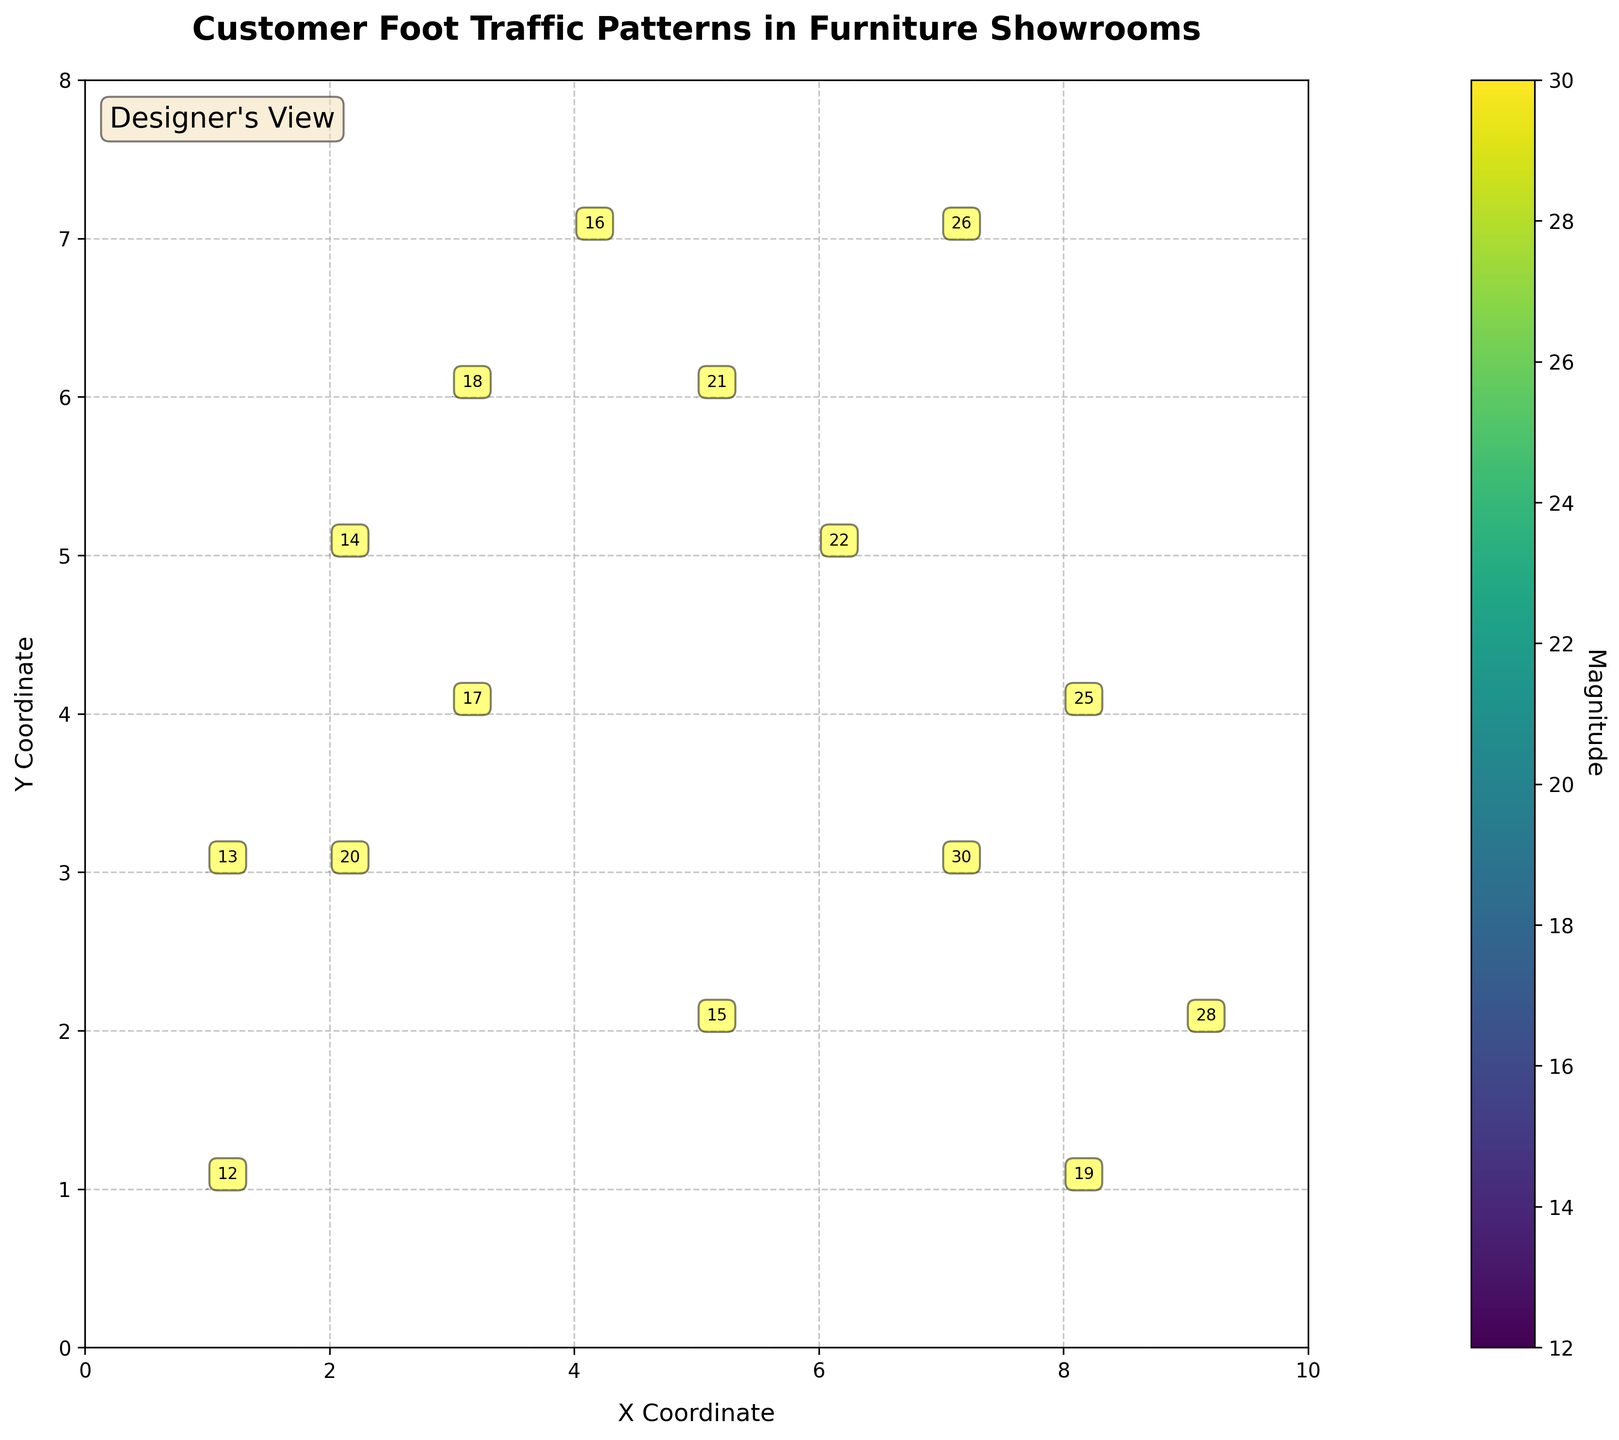What's the title of the figure? The title of the figure is displayed at the top, indicating the main focus of the plot. It provides an overview of the data being visualized.
Answer: Customer Foot Traffic Patterns in Furniture Showrooms How many data points are annotated on the plot? By counting all the annotations with numeric values on the plot, we can determine the number of data points represented.
Answer: 15 What are the x and y axis labels? The labels of the x and y coordinates are found along the axes of the plot. They describe what the coordinates represent in this context.
Answer: X Coordinate (x); Y Coordinate (y) Which data point has the highest magnitude value, and what is that value? By locating the data point with the highest numerical value in the annotations, we can identify both the x,y coordinates and the magnitude of this point.
Answer: Coordinates (7, 3); Magnitude 30 What is the direction of the vector at coordinates (9, 2)? By examining the direction of the arrow originating from the coordinates (9, 2) in the plot, we can determine the vector's direction.
Answer: Rightward and slightly upward Which data point shows a negative horizontal movement? How is it represented as a vector? By identifying vectors with negative horizontal components (u), we can determine which plot points indicate a leftward movement.
Answer: Coordinates (5, 2); Vector (-0.2, 0.4) Calculate the average magnitude of all data points. Add all the magnitude values and divide by the number of data points to determine the average magnitude. Sum = 20 + 15 + 25 + 18 + 22 + 12 + 30 + 16 + 28 + 14 + 21 + 19 + 17 + 26 + 13. Average magnitude = Total sum / 15.
Answer: 19.3 Compare the direction of movement for coordinates (3, 6) and (7, 7). How are they different? By analyzing the vectors at these coordinates, compare how they point differently in terms of direction.
Answer: (3, 6) moves leftward and slightly downward; (7, 7) moves leftward and upward Which quadrant in the plot has the least amount of foot traffic, as indicated by the magnitude values? By dividing the plot into four quadrants and summing up the magnitudes in each, we identify which quadrant has the lowest total magnitude for foot traffic.
Answer: Top-left (x<5, y>4) Is there any data point where both horizontal and vertical movements are negative? Identify its coordinates. Look for vectors with both negative horizontal (u) and vertical (v) components to find the corresponding coordinates.
Answer: (3, 6) 